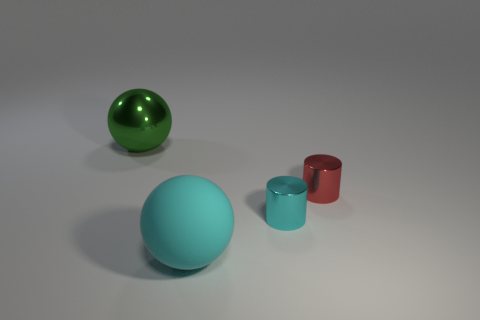Is there anything else that is made of the same material as the big cyan sphere?
Provide a short and direct response. No. Is the number of cyan matte objects behind the big cyan rubber object the same as the number of tiny yellow shiny objects?
Your answer should be very brief. Yes. What is the shape of the red object that is the same size as the cyan shiny cylinder?
Offer a very short reply. Cylinder. Are there any big cyan spheres in front of the shiny cylinder that is on the left side of the small red cylinder?
Provide a succinct answer. Yes. What number of tiny things are red metallic objects or cyan objects?
Your answer should be compact. 2. Is there a object of the same size as the green shiny sphere?
Your answer should be compact. Yes. What number of shiny things are either tiny gray cylinders or cyan cylinders?
Keep it short and to the point. 1. There is another object that is the same color as the rubber thing; what shape is it?
Provide a succinct answer. Cylinder. How many tiny brown spheres are there?
Offer a terse response. 0. Does the tiny thing left of the small red thing have the same material as the big object that is in front of the large green metallic ball?
Ensure brevity in your answer.  No. 